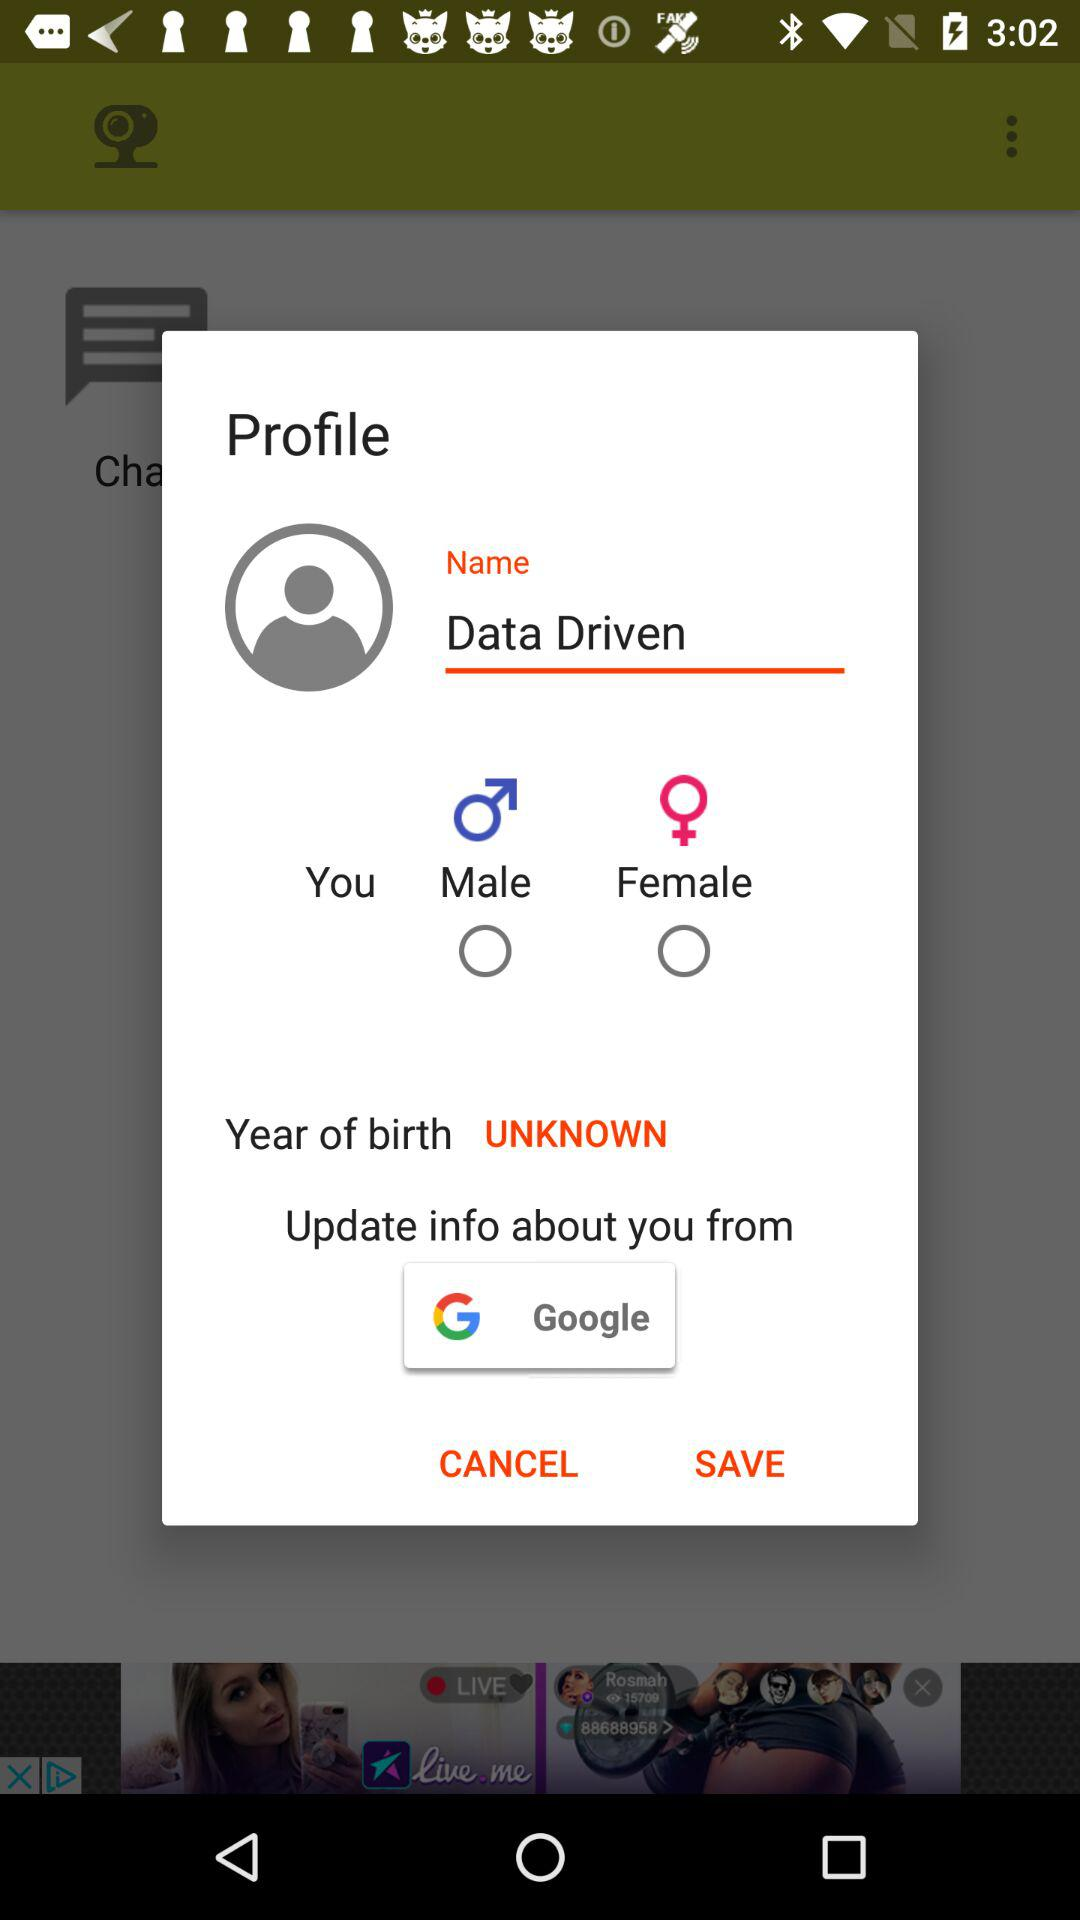What is the selected birth year? The selected birth year is unknown. 